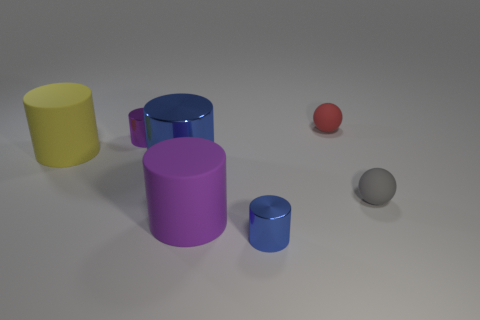Subtract all yellow cylinders. Subtract all cyan cubes. How many cylinders are left? 4 Add 1 red matte balls. How many objects exist? 8 Subtract all cylinders. How many objects are left? 2 Subtract 1 purple cylinders. How many objects are left? 6 Subtract all tiny brown shiny cylinders. Subtract all blue things. How many objects are left? 5 Add 2 red balls. How many red balls are left? 3 Add 1 small blue metal things. How many small blue metal things exist? 2 